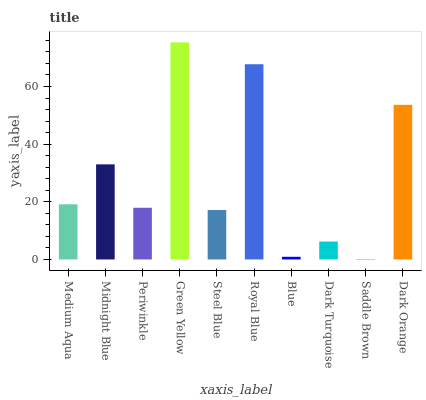Is Midnight Blue the minimum?
Answer yes or no. No. Is Midnight Blue the maximum?
Answer yes or no. No. Is Midnight Blue greater than Medium Aqua?
Answer yes or no. Yes. Is Medium Aqua less than Midnight Blue?
Answer yes or no. Yes. Is Medium Aqua greater than Midnight Blue?
Answer yes or no. No. Is Midnight Blue less than Medium Aqua?
Answer yes or no. No. Is Medium Aqua the high median?
Answer yes or no. Yes. Is Periwinkle the low median?
Answer yes or no. Yes. Is Blue the high median?
Answer yes or no. No. Is Dark Orange the low median?
Answer yes or no. No. 